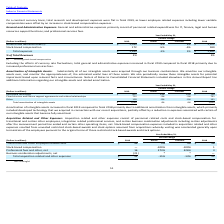Looking at Oracle Corporation's financial data, please calculate: By how much less did the company spend for stock-based compensation in 2019 compared to 2018? Based on the calculation: 180 -172 , the result is 8 (in millions). This is based on the information: "Stock-based compensation 172 -5% -5% 180 Stock-based compensation 172 -5% -5% 180..." The key data points involved are: 172, 180. Also, can you calculate: What is the average total expenses in 2018 and 2019? To answer this question, I need to perform calculations using the financial data. The calculation is: (1,282 + 1,265)/2 , which equals 1273.5 (in millions). This is based on the information: "Total expenses $ 1,265 -1% 1% $ 1,282 Total expenses $ 1,265 -1% 1% $ 1,282..." The key data points involved are: 1,265, 1,282. Also, can you calculate: What was the average general and administrative expenses for 2019 and 2018?  To answer this question, I need to perform calculations using the financial data. The calculation is: (1,093 + 1,102) / 2 , which equals 1097.5 (in millions). This is based on the information: "General and administrative (1) $ 1,093 -1% 2% $ 1,102 General and administrative (1) $ 1,093 -1% 2% $ 1,102..." The key data points involved are: 1,093, 1,102. Also, Which month did the financial year end in 2019? According to the financial document, Year Ended May 31. The relevant text states: "upport functions; and professional services fees. Year Ended May 31,..." Also, What are the components of general and administrative expenses? General and administrative expenses primarily consist of personnel related expenditures for IT, finance, legal and human resources support functions; and professional services fees.. The document states: "General and Administrative Expenses: General and administrative expenses primarily consist of personnel related expenditures for IT, finance, legal an..." Also, Why did total general and administrative expenses increase in fiscal 2019 relative to fiscal 2018? Excluding the effects of currency rate fluctuations, total general and administrative expenses increased in fiscal 2019 compared to fiscal 2018 primarily due to increased professional services fees. The document states: "Excluding the effects of currency rate fluctuations, total general and administrative expenses increased in fiscal 2019 compared to fiscal 2018 primar..." 